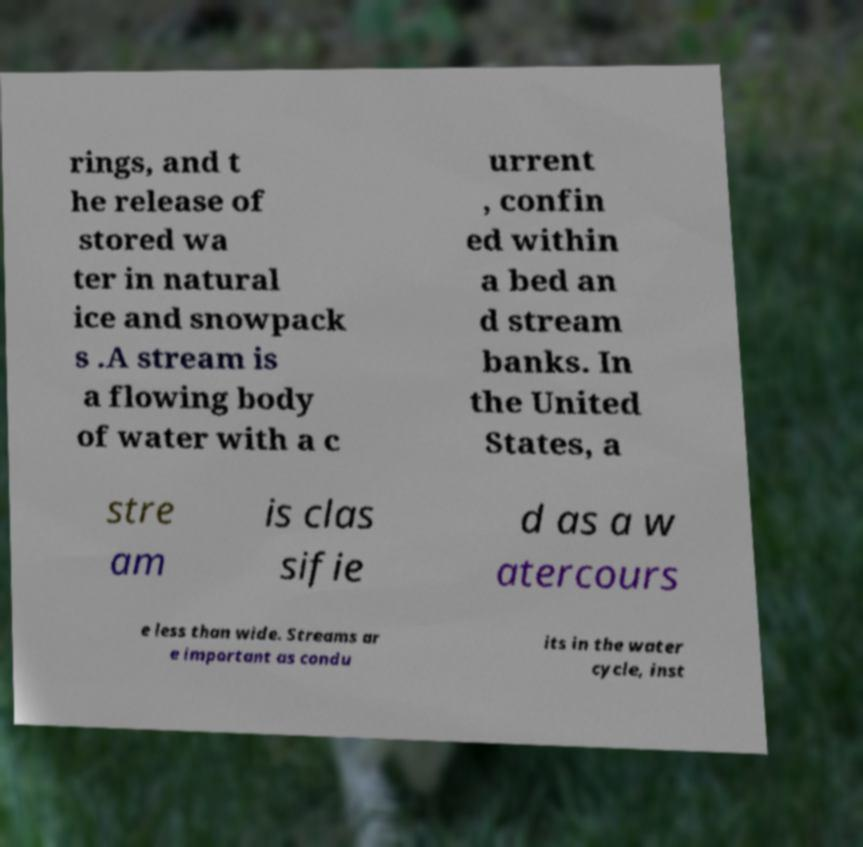For documentation purposes, I need the text within this image transcribed. Could you provide that? rings, and t he release of stored wa ter in natural ice and snowpack s .A stream is a flowing body of water with a c urrent , confin ed within a bed an d stream banks. In the United States, a stre am is clas sifie d as a w atercours e less than wide. Streams ar e important as condu its in the water cycle, inst 